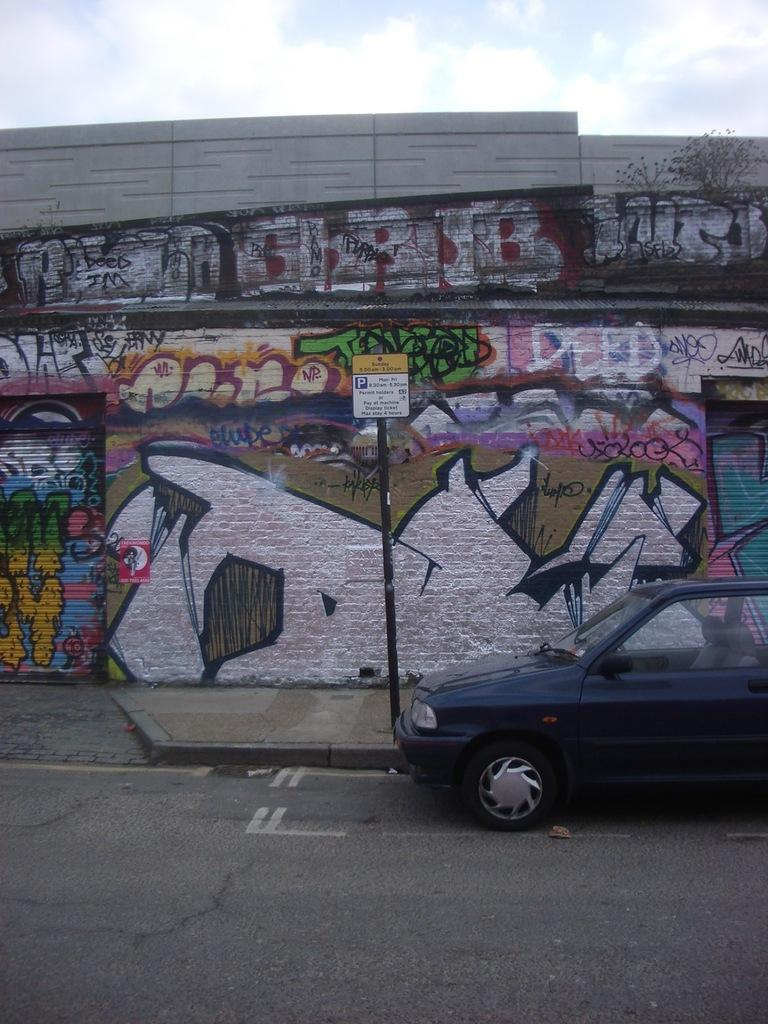What is on the road in the image? There is a vehicle on the road in the image. What is on a pole in the image? There is a board on a pole in the image. What is on a wall in the image? There is graffiti on a wall in the image. What can be seen in the background of the image? The sky is visible in the background of the image. Can you tell me how many snakes are crawling on the vehicle in the image? There are no snakes present in the image; it features a vehicle on the road, a board on a pole, graffiti on a wall, and a visible sky in the background. What type of vegetable is growing on the wall with graffiti? There are no vegetables present in the image; it features a vehicle on the road, a board on a pole, graffiti on a wall, and a visible sky in the background. 